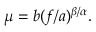Convert formula to latex. <formula><loc_0><loc_0><loc_500><loc_500>\begin{array} { r } { \mu = b ( f / a ) ^ { \beta / \alpha } . } \end{array}</formula> 